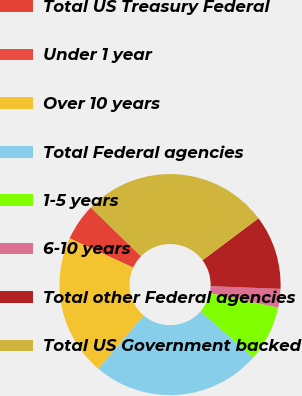Convert chart. <chart><loc_0><loc_0><loc_500><loc_500><pie_chart><fcel>Total US Treasury Federal<fcel>Under 1 year<fcel>Over 10 years<fcel>Total Federal agencies<fcel>1-5 years<fcel>6-10 years<fcel>Total other Federal agencies<fcel>Total US Government backed<nl><fcel>5.43%<fcel>0.0%<fcel>20.65%<fcel>24.75%<fcel>8.14%<fcel>2.71%<fcel>10.86%<fcel>27.46%<nl></chart> 